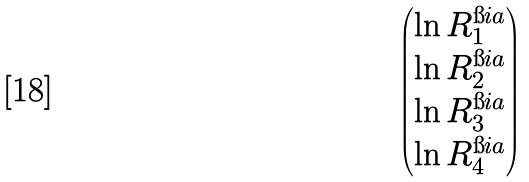Convert formula to latex. <formula><loc_0><loc_0><loc_500><loc_500>\begin{pmatrix} \ln R ^ { \i i a } _ { 1 } \\ \ln R ^ { \i i a } _ { 2 } \\ \ln R ^ { \i i a } _ { 3 } \\ \ln R ^ { \i i a } _ { 4 } \end{pmatrix}</formula> 